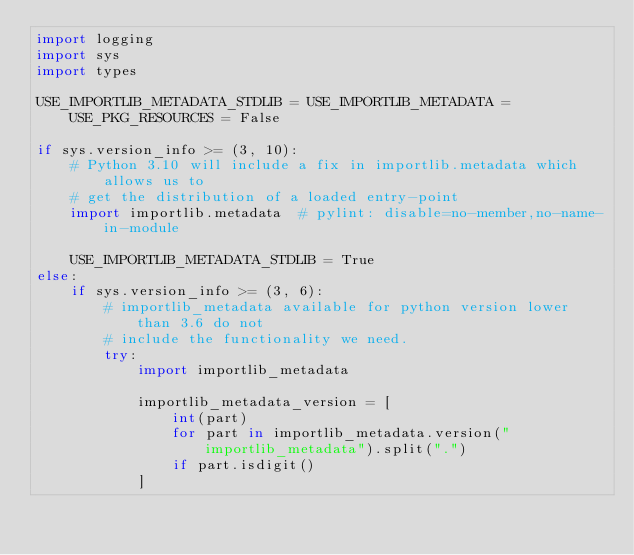Convert code to text. <code><loc_0><loc_0><loc_500><loc_500><_Python_>import logging
import sys
import types

USE_IMPORTLIB_METADATA_STDLIB = USE_IMPORTLIB_METADATA = USE_PKG_RESOURCES = False

if sys.version_info >= (3, 10):
    # Python 3.10 will include a fix in importlib.metadata which allows us to
    # get the distribution of a loaded entry-point
    import importlib.metadata  # pylint: disable=no-member,no-name-in-module

    USE_IMPORTLIB_METADATA_STDLIB = True
else:
    if sys.version_info >= (3, 6):
        # importlib_metadata available for python version lower than 3.6 do not
        # include the functionality we need.
        try:
            import importlib_metadata

            importlib_metadata_version = [
                int(part)
                for part in importlib_metadata.version("importlib_metadata").split(".")
                if part.isdigit()
            ]</code> 